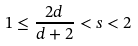<formula> <loc_0><loc_0><loc_500><loc_500>1 \leq \frac { 2 d } { d + 2 } < s < 2</formula> 